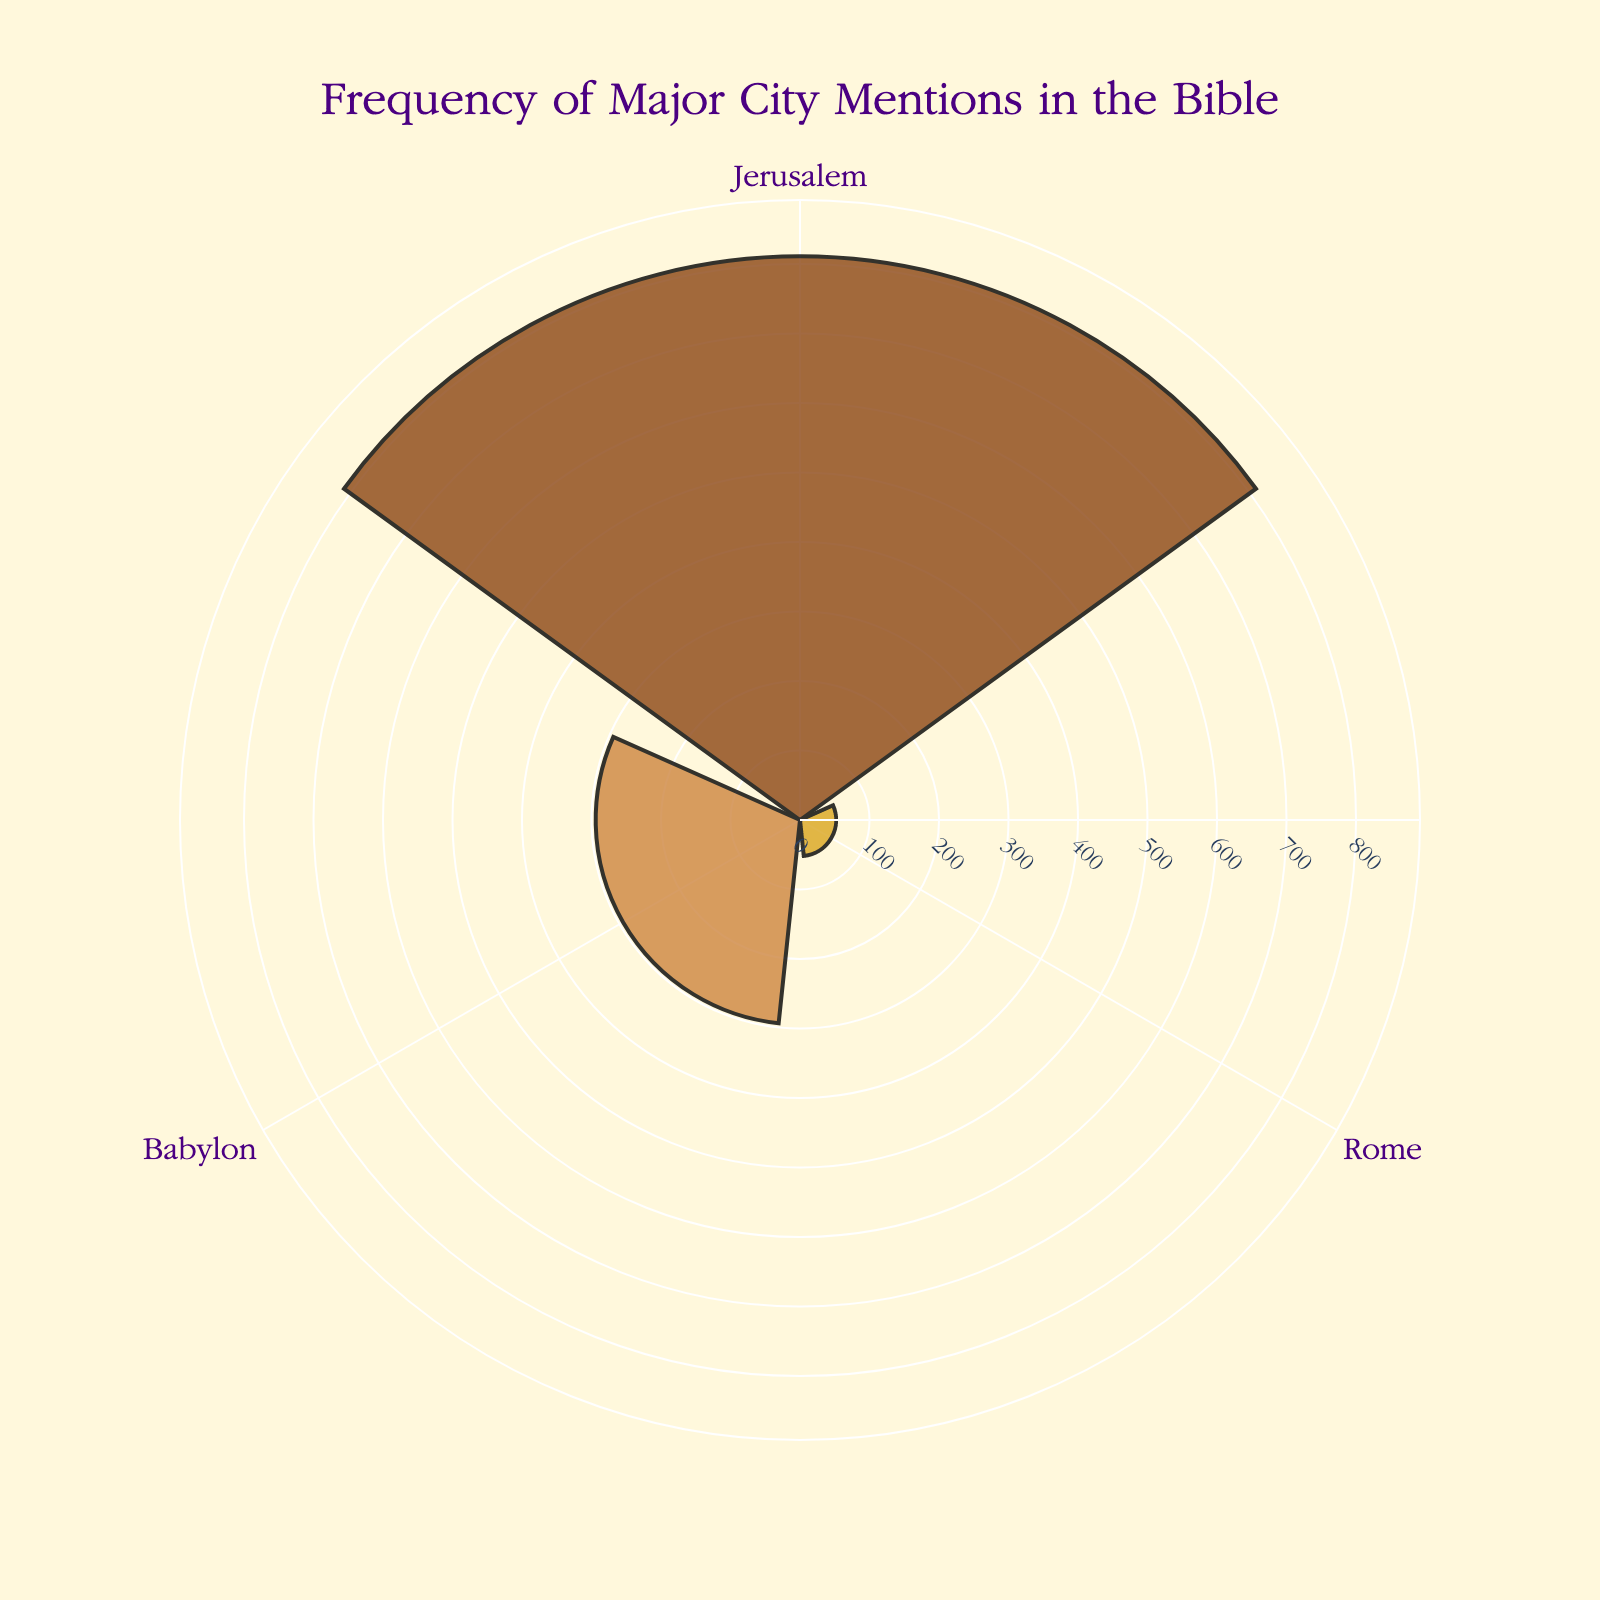what is the title of the figure? The title is located at the top of the figure, it reads "Frequency of Major City Mentions in the Bible". This helps to understand the context of the chart.
Answer: Frequency of Major City Mentions in the Bible What is the color scheme used for the cities? The cities are represented with different colors: a dark brown for Jerusalem, a golden color for Rome, and a lighter brown for Babylon. These colors distinguish the cities from each other.
Answer: Brown, Gold, Light Brown How many cities are represented in the chart? By observing the labels around the polar axis (theta), you can count the number of unique cities mentioned in the chart.
Answer: 3 Which city has the highest frequency of mentions? Look at the lengths of the bars that extend from the center of the rose chart. The longest bar represents the city with the highest frequency.
Answer: Jerusalem Which city has the lowest frequency of mentions? Similarly, find the shortest bar in the chart as it represents the lowest frequency of mentions.
Answer: Rome What is the sum of the mentions of all the cities? To find the total, add the number of mentions for each city: Jerusalem (811), Rome (52), and Babylon (294). Therefore, 811 + 52 + 294 = 1157.
Answer: 1157 How many more times is Jerusalem mentioned compared to Rome? Subtract the number of mentions of Rome (52) from the number of mentions of Jerusalem (811). So, 811 - 52 = 759.
Answer: 759 What is the ratio of mentions between Jerusalem and Babylon? Divide the number of mentions of Jerusalem (811) by the number of mentions of Babylon (294). The ratio is approximately 2.76.
Answer: 2.76 Which two cities have a combined total of mentions less than Jerusalem alone? Add the number of mentions of Rome (52) and Babylon (294) and compare it with Jerusalem's mentions (811). 52 + 294 = 346, which is less than 811.
Answer: Rome and Babylon Is the difference in mentions between Babylon and Rome greater than 200? Subtract the number of mentions of Rome (52) from Babylon (294). So, 294 - 52 = 242, which is greater than 200.
Answer: Yes 